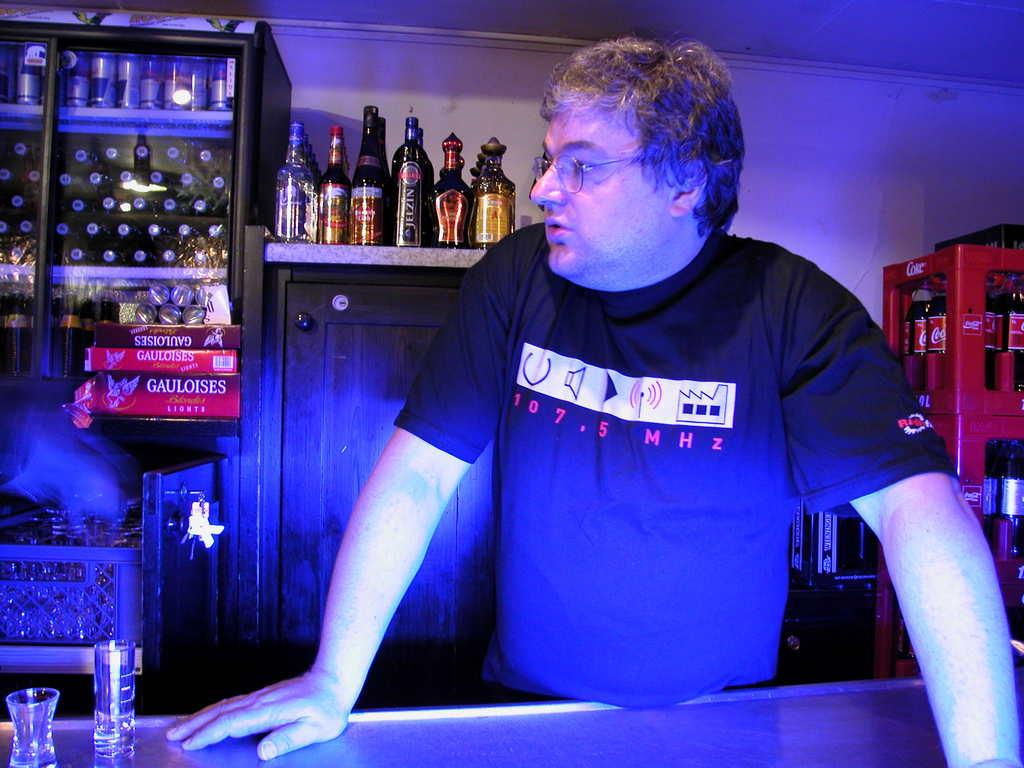<image>
Relay a brief, clear account of the picture shown. A man wears a shirt with 107.5 MHz in red. 